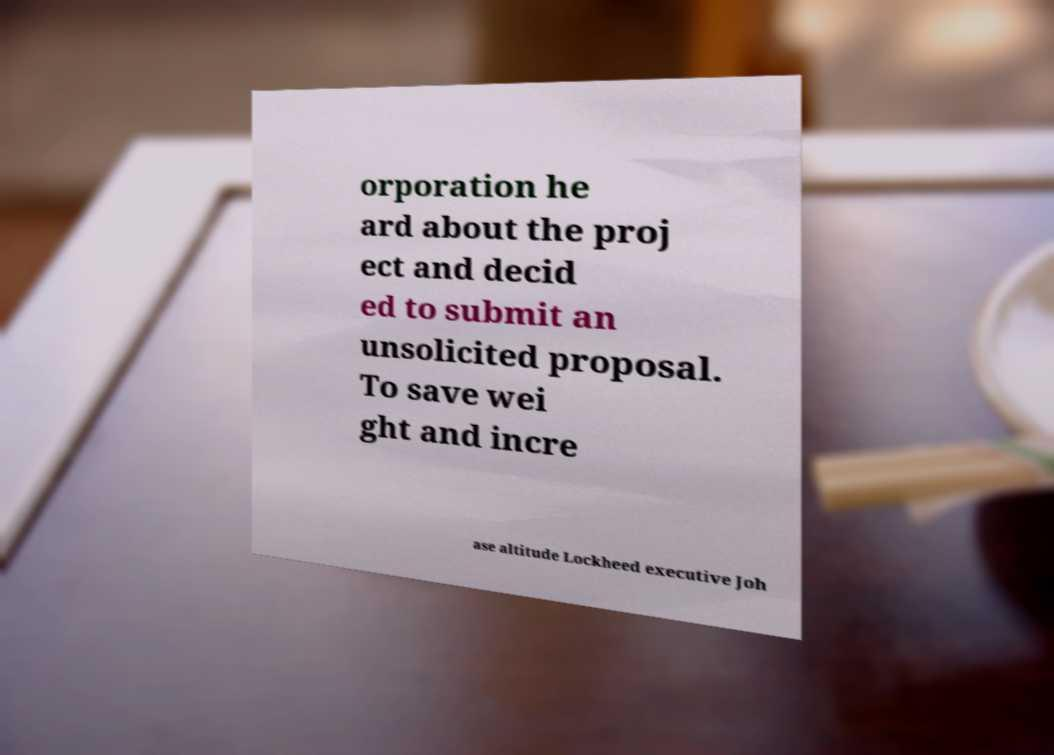Please read and relay the text visible in this image. What does it say? orporation he ard about the proj ect and decid ed to submit an unsolicited proposal. To save wei ght and incre ase altitude Lockheed executive Joh 